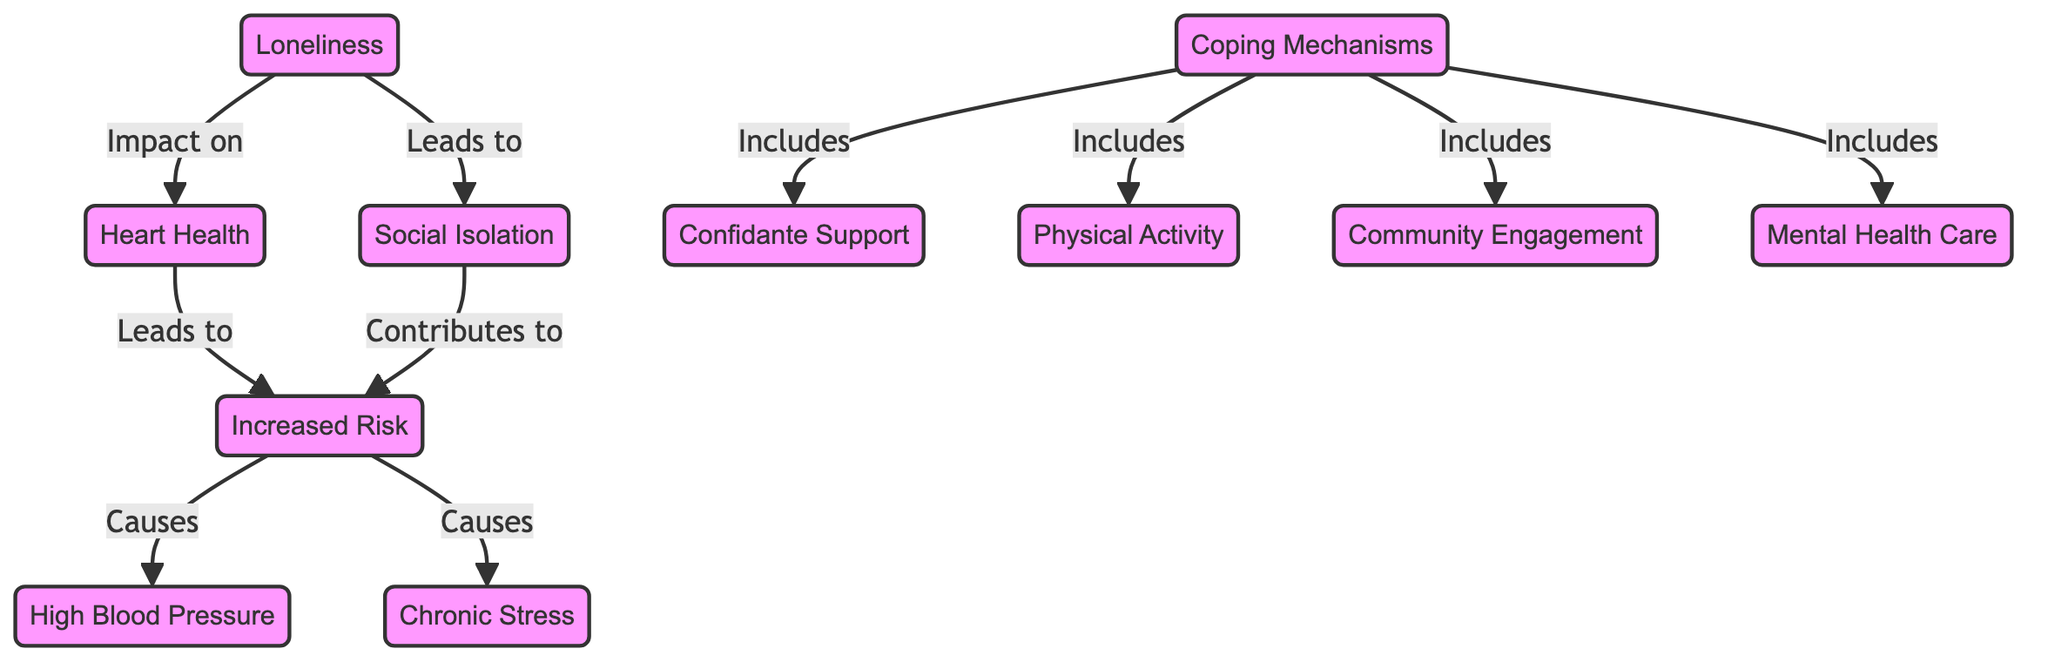What is the primary factor influencing heart health in this diagram? The diagram indicates "Loneliness" as the primary factor that impacts heart health. This relationship is depicted as a direct link from "Loneliness" to "Heart Health."
Answer: Loneliness How many coping mechanisms are listed in the diagram? The diagram includes four coping mechanisms: "Confidante Support," "Physical Activity," "Community Engagement," and "Mental Health Care." Thus, counting these nodes gives a total of four.
Answer: 4 Which condition is a direct consequence of increased risk? The diagram shows "High Blood Pressure" as one of the conditions caused by "Increased Risk." This is represented by a direct linking arrow from "Increased Risk" to "High Blood Pressure."
Answer: High Blood Pressure What effect does loneliness have on social interactions? The diagram states that "Loneliness" leads to "Social Isolation," illustrating the negative impact loneliness has on social interactions through a direct connection between the two.
Answer: Social Isolation Which coping mechanism indicates support from others? The diagram specifically points to "Confidante Support" as a coping mechanism that involves receiving support from trusted individuals, emphasizing the importance of personal connections in coping with loneliness.
Answer: Confidante Support What are the two primary outcomes listed as results of increased risk? According to the diagram, "High Blood Pressure" and "Chronic Stress" are both direct outcomes stemming from "Increased Risk." These outcomes reflect the negative health impacts associated with increased risk.
Answer: High Blood Pressure, Chronic Stress Which node indicates a connection to community activities? The node "Community Engagement" showcases activities that involve social participation and connection to the community as part of coping mechanisms to counteract loneliness. It is highlighted as one of the strategies for fostering connection.
Answer: Community Engagement How does social isolation contribute to health risk? The diagram illustrates that "Social Isolation" contributes to "Increased Risk." It shows that being socially isolated has a direct link to elevating health risks, thereby reinforcing the need for social connections.
Answer: Increased Risk Which two factors stem directly from loneliness? "Social Isolation" and its impact on "Heart Health" stem directly from "Loneliness," as indicated by the arrows leading from the loneliness node to both of these outcomes. This shows the divergent effects of loneliness.
Answer: Social Isolation, Heart Health 